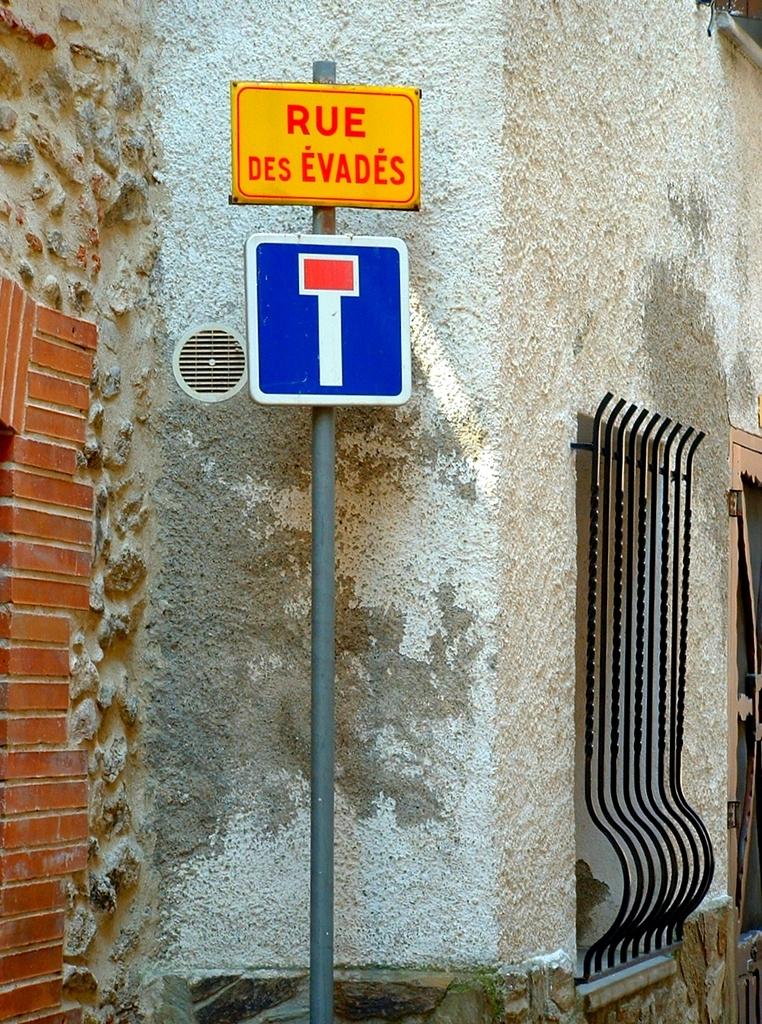What does this sign say?
Offer a very short reply. Rue des evades. 